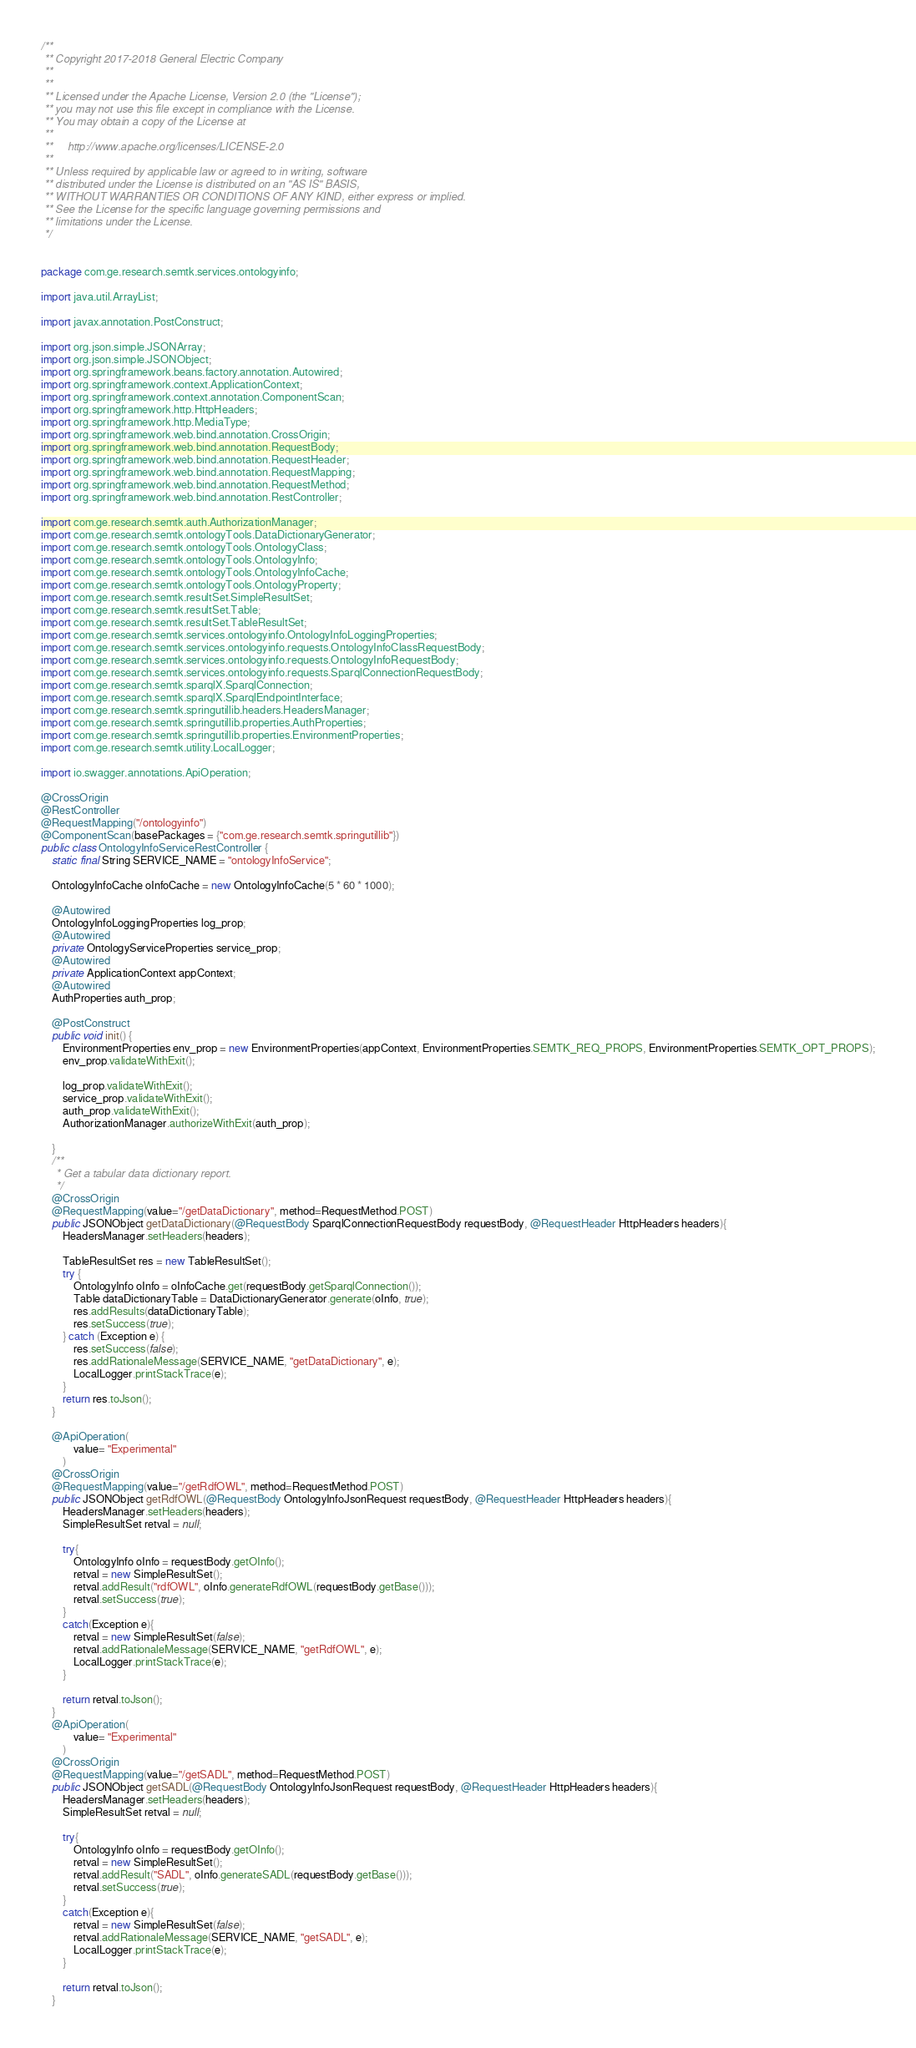<code> <loc_0><loc_0><loc_500><loc_500><_Java_>/**
 ** Copyright 2017-2018 General Electric Company
 **
 **
 ** Licensed under the Apache License, Version 2.0 (the "License");
 ** you may not use this file except in compliance with the License.
 ** You may obtain a copy of the License at
 ** 
 **     http://www.apache.org/licenses/LICENSE-2.0
 ** 
 ** Unless required by applicable law or agreed to in writing, software
 ** distributed under the License is distributed on an "AS IS" BASIS,
 ** WITHOUT WARRANTIES OR CONDITIONS OF ANY KIND, either express or implied.
 ** See the License for the specific language governing permissions and
 ** limitations under the License.
 */


package com.ge.research.semtk.services.ontologyinfo;

import java.util.ArrayList;

import javax.annotation.PostConstruct;

import org.json.simple.JSONArray;
import org.json.simple.JSONObject;
import org.springframework.beans.factory.annotation.Autowired;
import org.springframework.context.ApplicationContext;
import org.springframework.context.annotation.ComponentScan;
import org.springframework.http.HttpHeaders;
import org.springframework.http.MediaType;
import org.springframework.web.bind.annotation.CrossOrigin;
import org.springframework.web.bind.annotation.RequestBody;
import org.springframework.web.bind.annotation.RequestHeader;
import org.springframework.web.bind.annotation.RequestMapping;
import org.springframework.web.bind.annotation.RequestMethod;
import org.springframework.web.bind.annotation.RestController;

import com.ge.research.semtk.auth.AuthorizationManager;
import com.ge.research.semtk.ontologyTools.DataDictionaryGenerator;
import com.ge.research.semtk.ontologyTools.OntologyClass;
import com.ge.research.semtk.ontologyTools.OntologyInfo;
import com.ge.research.semtk.ontologyTools.OntologyInfoCache;
import com.ge.research.semtk.ontologyTools.OntologyProperty;
import com.ge.research.semtk.resultSet.SimpleResultSet;
import com.ge.research.semtk.resultSet.Table;
import com.ge.research.semtk.resultSet.TableResultSet;
import com.ge.research.semtk.services.ontologyinfo.OntologyInfoLoggingProperties;
import com.ge.research.semtk.services.ontologyinfo.requests.OntologyInfoClassRequestBody;
import com.ge.research.semtk.services.ontologyinfo.requests.OntologyInfoRequestBody;
import com.ge.research.semtk.services.ontologyinfo.requests.SparqlConnectionRequestBody;
import com.ge.research.semtk.sparqlX.SparqlConnection;
import com.ge.research.semtk.sparqlX.SparqlEndpointInterface;
import com.ge.research.semtk.springutillib.headers.HeadersManager;
import com.ge.research.semtk.springutillib.properties.AuthProperties;
import com.ge.research.semtk.springutillib.properties.EnvironmentProperties;
import com.ge.research.semtk.utility.LocalLogger;

import io.swagger.annotations.ApiOperation;

@CrossOrigin
@RestController
@RequestMapping("/ontologyinfo")
@ComponentScan(basePackages = {"com.ge.research.semtk.springutillib"})
public class OntologyInfoServiceRestController {
 	static final String SERVICE_NAME = "ontologyInfoService";

 	OntologyInfoCache oInfoCache = new OntologyInfoCache(5 * 60 * 1000);
 	
	@Autowired
	OntologyInfoLoggingProperties log_prop;
	@Autowired
	private OntologyServiceProperties service_prop;
	@Autowired 
	private ApplicationContext appContext;
	@Autowired
	AuthProperties auth_prop;

	@PostConstruct
    public void init() {
		EnvironmentProperties env_prop = new EnvironmentProperties(appContext, EnvironmentProperties.SEMTK_REQ_PROPS, EnvironmentProperties.SEMTK_OPT_PROPS);
		env_prop.validateWithExit();

		log_prop.validateWithExit();
		service_prop.validateWithExit();
		auth_prop.validateWithExit();
		AuthorizationManager.authorizeWithExit(auth_prop);

	}
	/**
	 * Get a tabular data dictionary report.
	 */
	@CrossOrigin
	@RequestMapping(value="/getDataDictionary", method=RequestMethod.POST)
	public JSONObject getDataDictionary(@RequestBody SparqlConnectionRequestBody requestBody, @RequestHeader HttpHeaders headers){
		HeadersManager.setHeaders(headers);
	
    	TableResultSet res = new TableResultSet();	
	    try {
	    	OntologyInfo oInfo = oInfoCache.get(requestBody.getSparqlConnection());
	    	Table dataDictionaryTable = DataDictionaryGenerator.generate(oInfo, true);
	    	res.addResults(dataDictionaryTable);
	    	res.setSuccess(true);
	    } catch (Exception e) {
	    	res.setSuccess(false);
	    	res.addRationaleMessage(SERVICE_NAME, "getDataDictionary", e);
	    	LocalLogger.printStackTrace(e);
	    }
	    return res.toJson();
	}
	
	@ApiOperation(
		    value= "Experimental"
		)
	@CrossOrigin
	@RequestMapping(value="/getRdfOWL", method=RequestMethod.POST)
	public JSONObject getRdfOWL(@RequestBody OntologyInfoJsonRequest requestBody, @RequestHeader HttpHeaders headers){
		HeadersManager.setHeaders(headers);
		SimpleResultSet retval = null;
		
		try{
			OntologyInfo oInfo = requestBody.getOInfo();
			retval = new SimpleResultSet(); 
			retval.addResult("rdfOWL", oInfo.generateRdfOWL(requestBody.getBase()));
			retval.setSuccess(true);
		}
		catch(Exception e){
			retval = new SimpleResultSet(false);
			retval.addRationaleMessage(SERVICE_NAME, "getRdfOWL", e);
			LocalLogger.printStackTrace(e);
		}
		
		return retval.toJson();		
	}
	@ApiOperation(
		    value= "Experimental"
		)
	@CrossOrigin
	@RequestMapping(value="/getSADL", method=RequestMethod.POST)
	public JSONObject getSADL(@RequestBody OntologyInfoJsonRequest requestBody, @RequestHeader HttpHeaders headers){
		HeadersManager.setHeaders(headers);
		SimpleResultSet retval = null;
		
		try{
			OntologyInfo oInfo = requestBody.getOInfo();
			retval = new SimpleResultSet(); 
			retval.addResult("SADL", oInfo.generateSADL(requestBody.getBase()));
			retval.setSuccess(true);
		}
		catch(Exception e){
			retval = new SimpleResultSet(false);
			retval.addRationaleMessage(SERVICE_NAME, "getSADL", e);
			LocalLogger.printStackTrace(e);
		}
		
		return retval.toJson();		
	}
</code> 